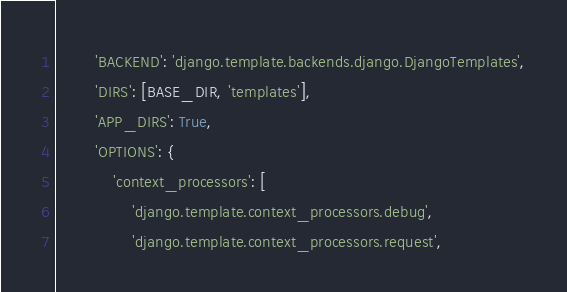<code> <loc_0><loc_0><loc_500><loc_500><_Python_>        'BACKEND': 'django.template.backends.django.DjangoTemplates',
        'DIRS': [BASE_DIR, 'templates'],
        'APP_DIRS': True,
        'OPTIONS': {
            'context_processors': [
                'django.template.context_processors.debug',
                'django.template.context_processors.request',</code> 